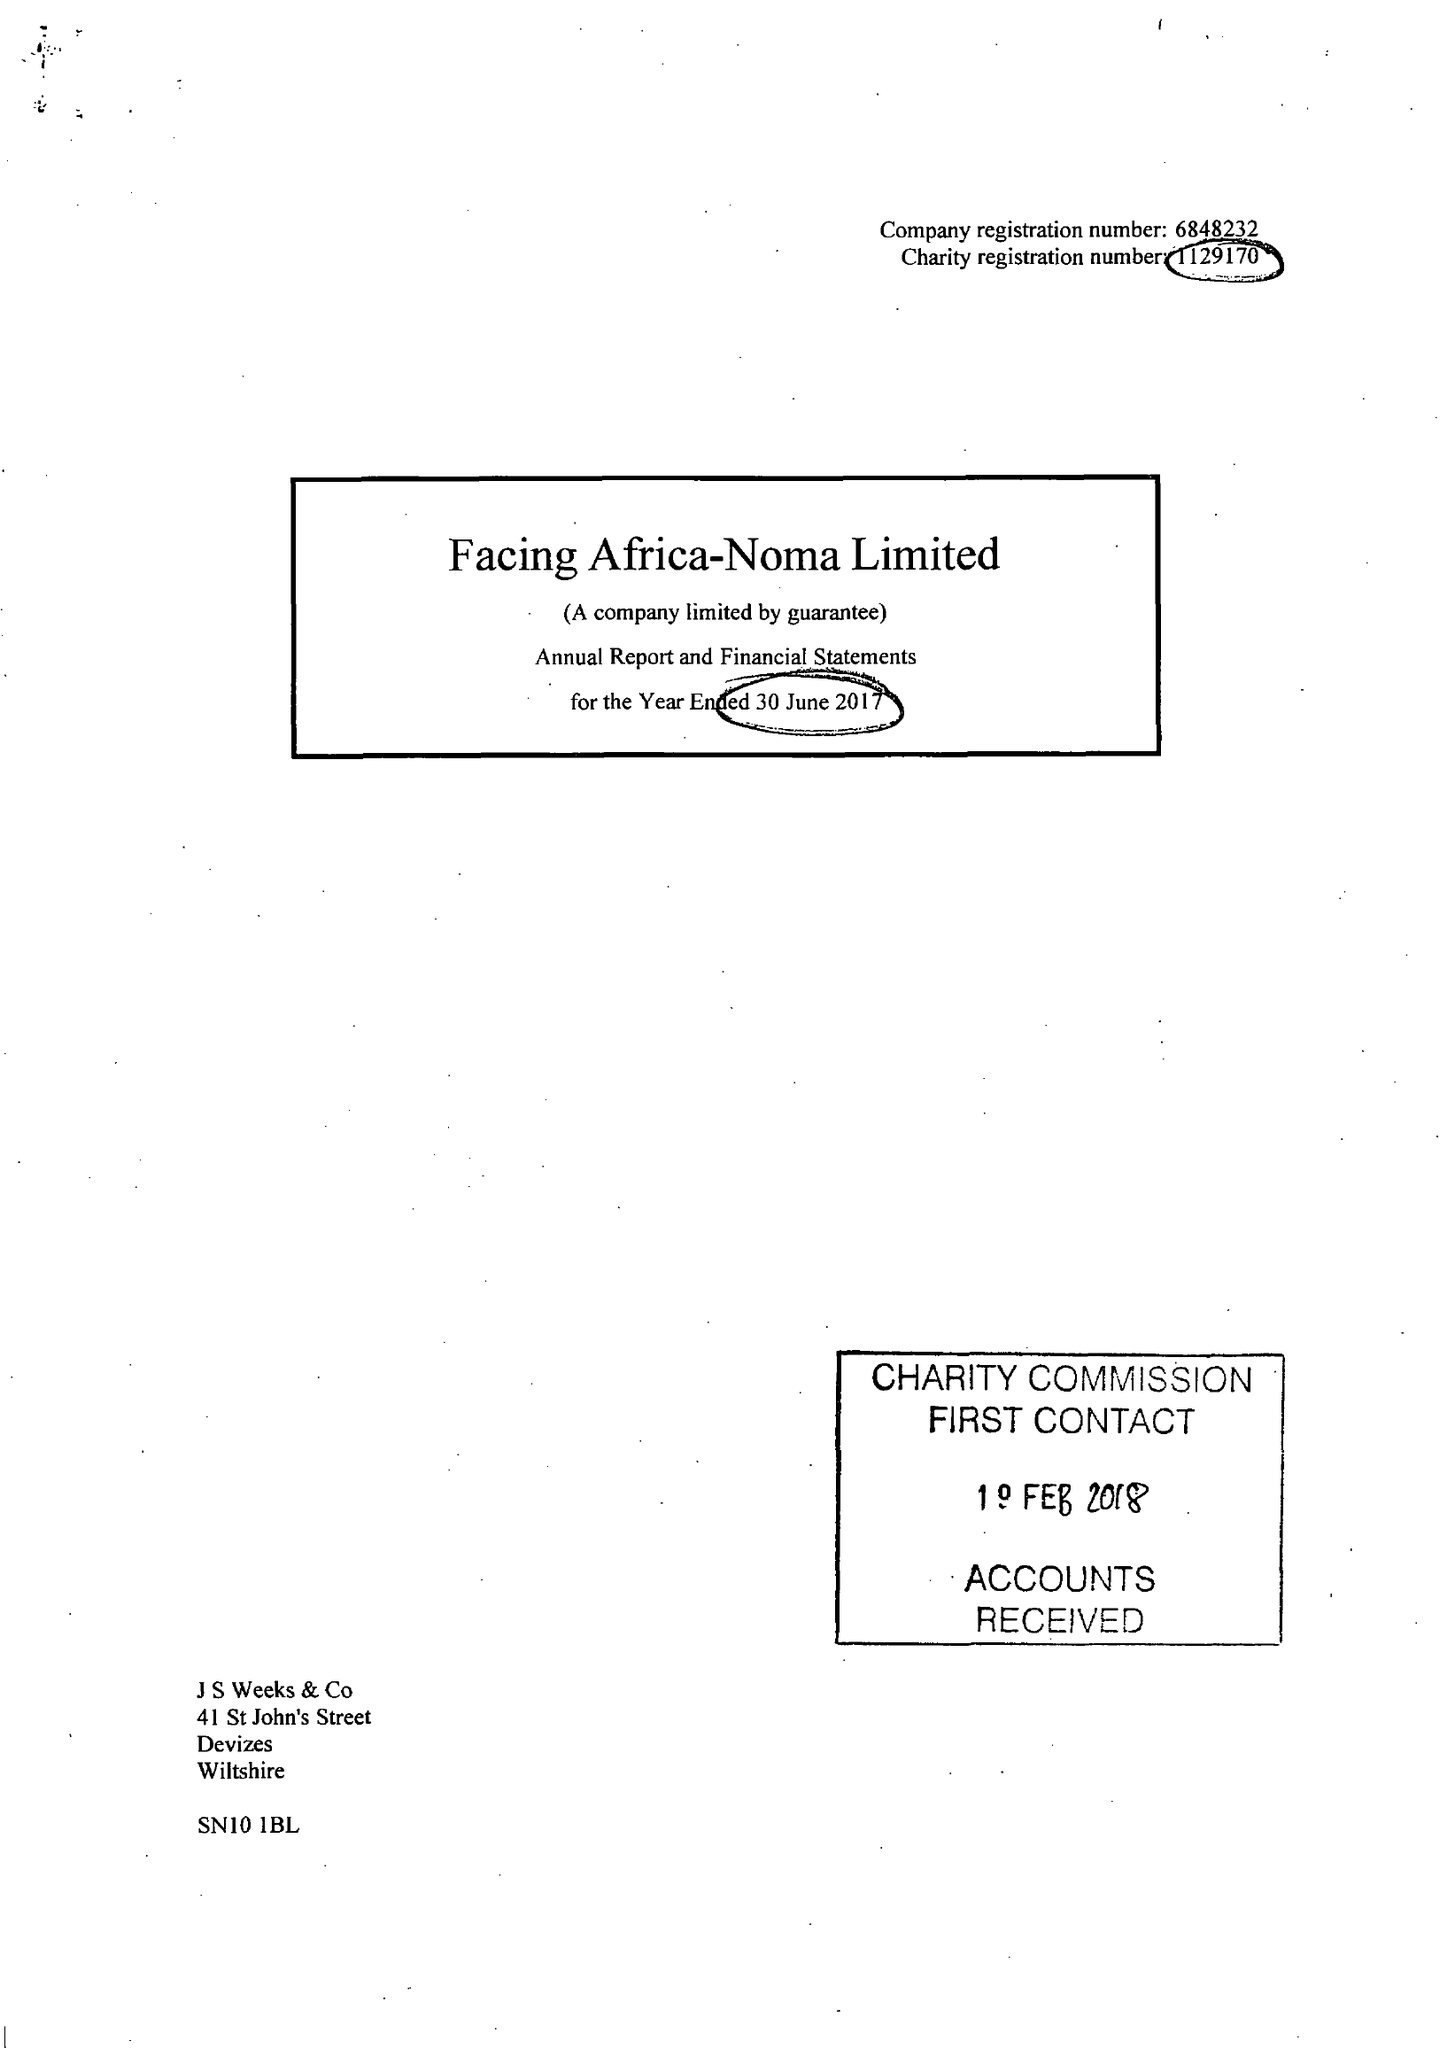What is the value for the report_date?
Answer the question using a single word or phrase. 2017-06-30 